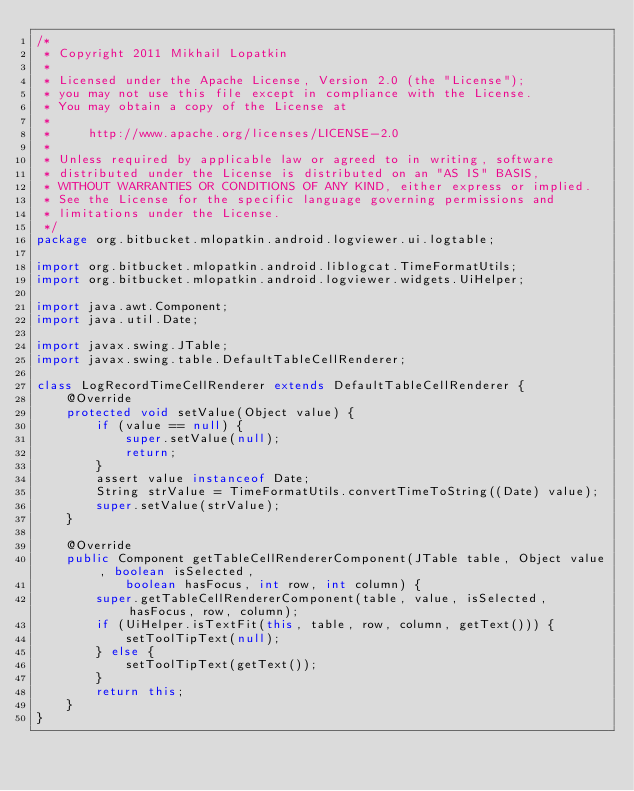<code> <loc_0><loc_0><loc_500><loc_500><_Java_>/*
 * Copyright 2011 Mikhail Lopatkin
 *
 * Licensed under the Apache License, Version 2.0 (the "License");
 * you may not use this file except in compliance with the License.
 * You may obtain a copy of the License at
 *
 *     http://www.apache.org/licenses/LICENSE-2.0
 *
 * Unless required by applicable law or agreed to in writing, software
 * distributed under the License is distributed on an "AS IS" BASIS,
 * WITHOUT WARRANTIES OR CONDITIONS OF ANY KIND, either express or implied.
 * See the License for the specific language governing permissions and
 * limitations under the License.
 */
package org.bitbucket.mlopatkin.android.logviewer.ui.logtable;

import org.bitbucket.mlopatkin.android.liblogcat.TimeFormatUtils;
import org.bitbucket.mlopatkin.android.logviewer.widgets.UiHelper;

import java.awt.Component;
import java.util.Date;

import javax.swing.JTable;
import javax.swing.table.DefaultTableCellRenderer;

class LogRecordTimeCellRenderer extends DefaultTableCellRenderer {
    @Override
    protected void setValue(Object value) {
        if (value == null) {
            super.setValue(null);
            return;
        }
        assert value instanceof Date;
        String strValue = TimeFormatUtils.convertTimeToString((Date) value);
        super.setValue(strValue);
    }

    @Override
    public Component getTableCellRendererComponent(JTable table, Object value, boolean isSelected,
            boolean hasFocus, int row, int column) {
        super.getTableCellRendererComponent(table, value, isSelected, hasFocus, row, column);
        if (UiHelper.isTextFit(this, table, row, column, getText())) {
            setToolTipText(null);
        } else {
            setToolTipText(getText());
        }
        return this;
    }
}
</code> 